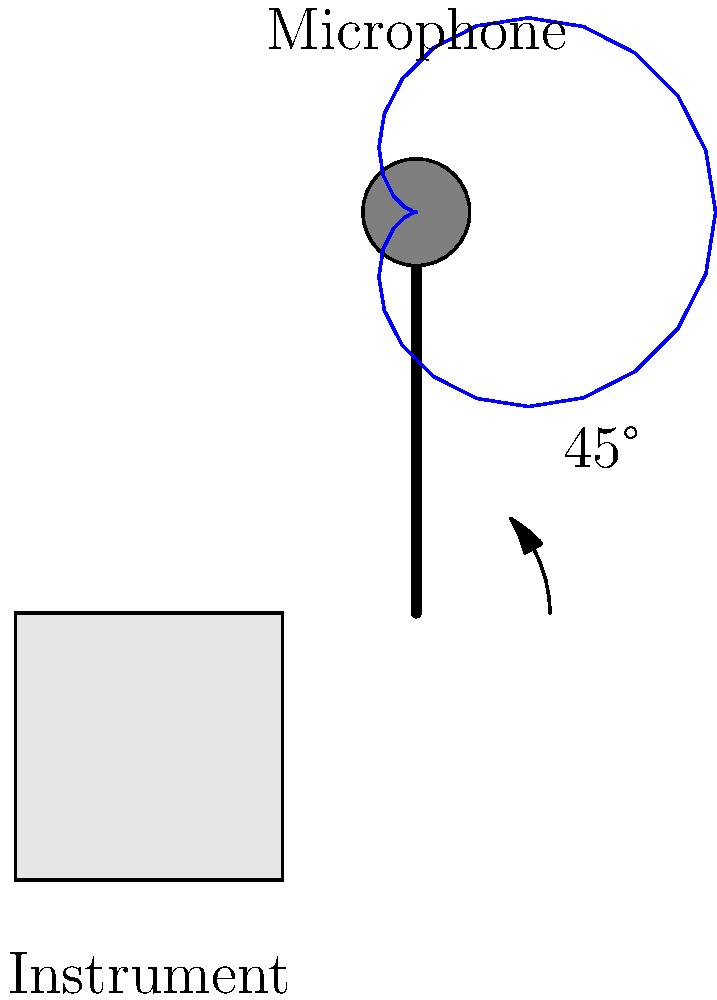As a record producer working on a fusion album, you're recording a unique stringed instrument. Given the cardioid polar pattern of the microphone shown in the diagram, what is the optimal angle (in degrees) between the microphone's axis and the instrument's surface to capture both direct sound and room ambience while minimizing potential feedback issues? To determine the optimal microphone placement angle, we need to consider several factors:

1. Cardioid polar pattern: The diagram shows a cardioid pattern, which is most sensitive to sound from the front and least sensitive from the rear.

2. Direct sound vs. room ambience: We want to capture both the direct sound from the instrument and some room ambience for a natural sound.

3. Feedback rejection: Placing the microphone at an angle helps reduce potential feedback issues in live settings or monitoring situations.

4. Off-axis coloration: As we move off-axis, there's some high-frequency attenuation, which can be desirable for certain instruments.

5. Proximity effect: Cardioid microphones exhibit increased bass response when close to the source, which can be managed by angling the microphone.

The optimal angle that balances these factors is typically around 45 degrees. This angle:

- Captures direct sound from the instrument
- Allows some room ambience to be picked up
- Provides good feedback rejection
- Offers a slight off-axis coloration that can be musically pleasing
- Helps manage proximity effect

The 45-degree angle is indicated in the diagram, showing that this placement achieves the desired balance for recording the unique stringed instrument in a fusion album context.
Answer: 45 degrees 